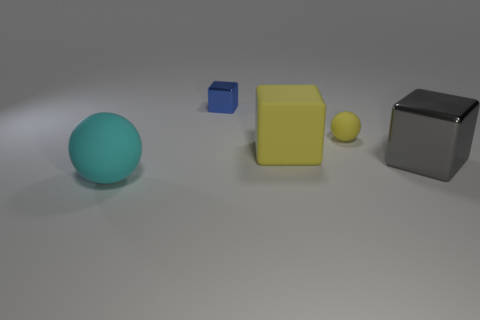What is the shape of the rubber thing that is behind the big matte thing behind the shiny object that is on the right side of the large yellow matte thing?
Give a very brief answer. Sphere. What is the color of the tiny object that is the same shape as the large gray thing?
Make the answer very short. Blue. There is a cube that is on the right side of the big matte object right of the cyan rubber sphere; what color is it?
Keep it short and to the point. Gray. There is another thing that is the same shape as the tiny rubber thing; what is its size?
Your response must be concise. Large. How many yellow spheres have the same material as the large gray block?
Provide a succinct answer. 0. There is a ball behind the big gray metal cube; what number of spheres are on the left side of it?
Your answer should be very brief. 1. There is a tiny metal cube; are there any tiny yellow rubber spheres behind it?
Offer a very short reply. No. There is a big matte thing in front of the big gray metallic thing; is its shape the same as the small yellow object?
Keep it short and to the point. Yes. What is the material of the cube that is the same color as the tiny matte object?
Your answer should be very brief. Rubber. How many small metallic things have the same color as the large matte block?
Your answer should be very brief. 0. 